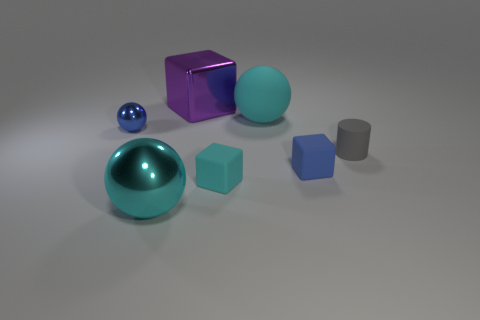Do the big rubber ball and the big metallic ball have the same color?
Provide a succinct answer. Yes. What color is the object that is to the right of the purple metal block and in front of the blue matte thing?
Offer a very short reply. Cyan. There is a large purple shiny thing; are there any small blocks on the right side of it?
Your response must be concise. Yes. There is a tiny blue thing that is left of the purple metal thing; how many big cyan metallic balls are behind it?
Keep it short and to the point. 0. There is another cyan thing that is made of the same material as the tiny cyan thing; what size is it?
Give a very brief answer. Large. How big is the blue sphere?
Offer a very short reply. Small. Is the small cyan cube made of the same material as the small ball?
Give a very brief answer. No. What number of cylinders are small blue objects or blue matte things?
Offer a terse response. 0. The shiny thing left of the cyan ball that is in front of the small matte cylinder is what color?
Make the answer very short. Blue. What size is the cube that is the same color as the tiny shiny sphere?
Offer a terse response. Small. 